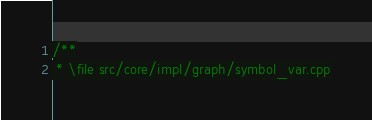<code> <loc_0><loc_0><loc_500><loc_500><_C++_>/**
 * \file src/core/impl/graph/symbol_var.cpp</code> 